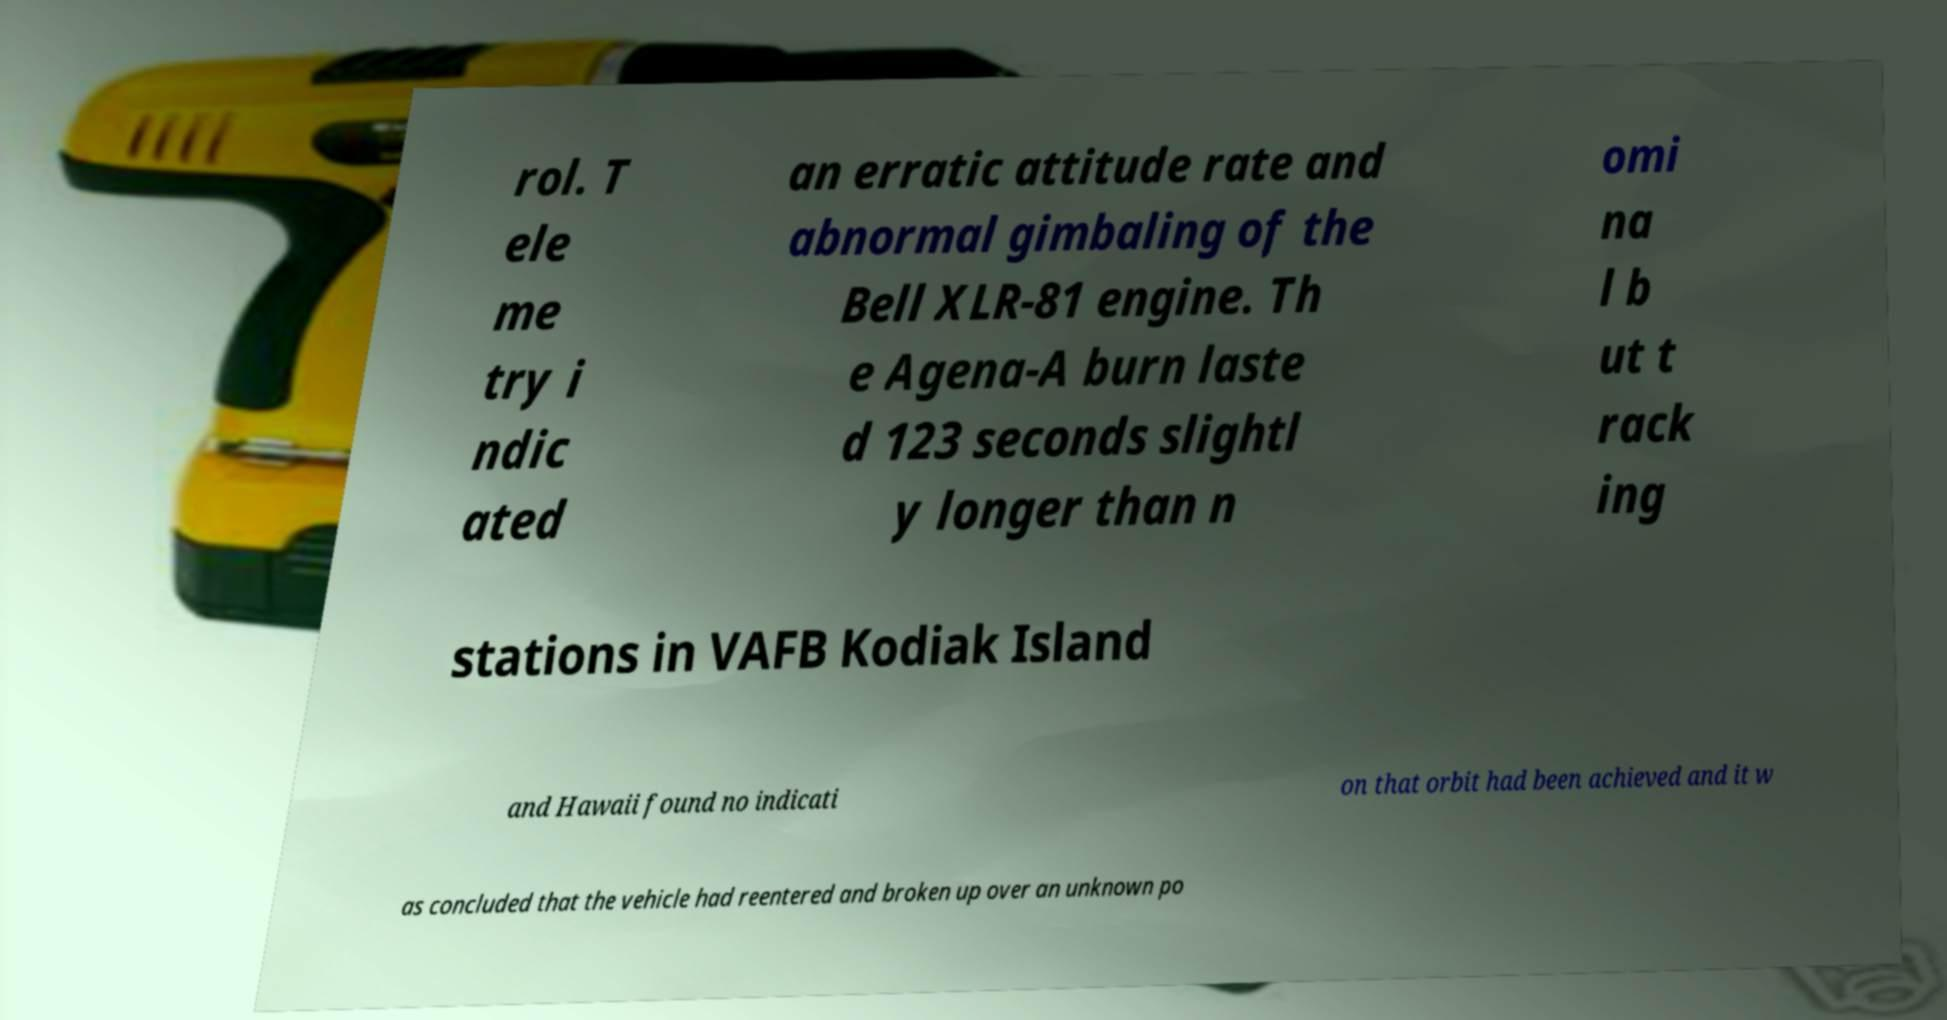Could you extract and type out the text from this image? rol. T ele me try i ndic ated an erratic attitude rate and abnormal gimbaling of the Bell XLR-81 engine. Th e Agena-A burn laste d 123 seconds slightl y longer than n omi na l b ut t rack ing stations in VAFB Kodiak Island and Hawaii found no indicati on that orbit had been achieved and it w as concluded that the vehicle had reentered and broken up over an unknown po 